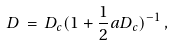<formula> <loc_0><loc_0><loc_500><loc_500>D \, = \, D _ { c } ( 1 + \frac { 1 } { 2 } a D _ { c } ) ^ { - 1 } \, ,</formula> 